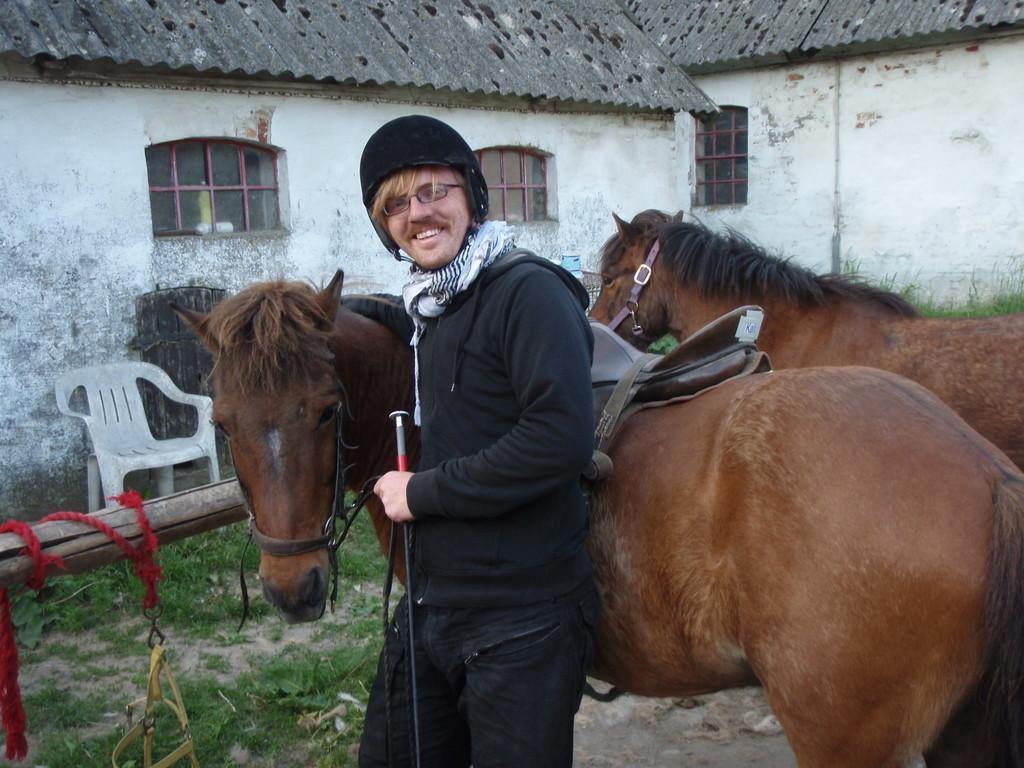In one or two sentences, can you explain what this image depicts? In this image there is a person wearing scarf and helmet. He is standing beside the horse. Right side there is a horse. Behind there is grass. Left side there is a wooden trunk tied with a rope. There is a chair on the grassland. Background there are houses having windows. 